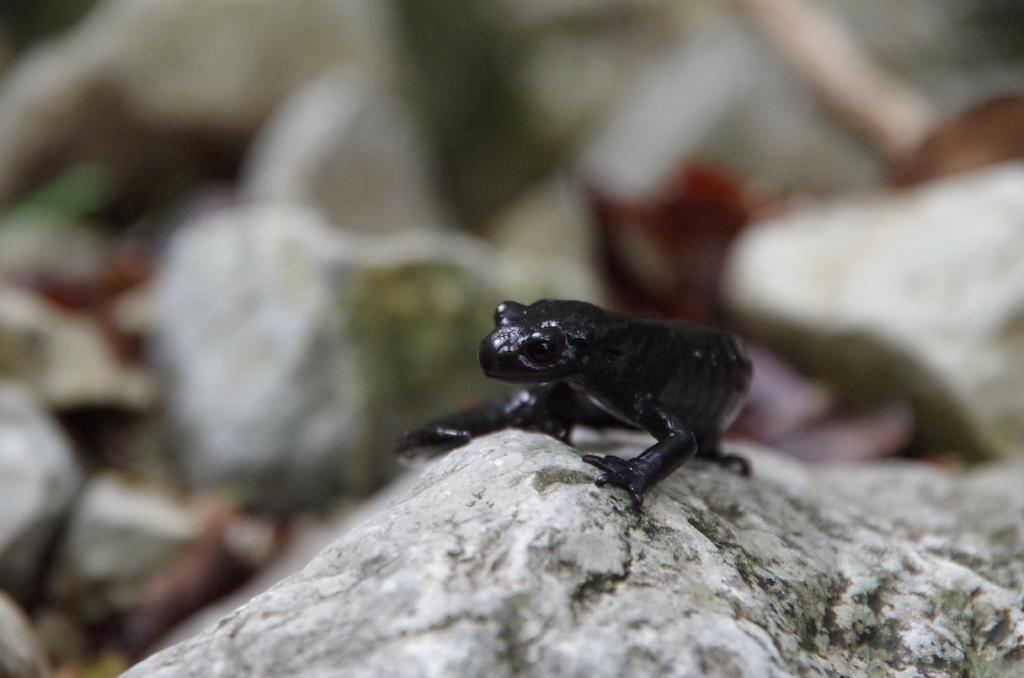Could you give a brief overview of what you see in this image? At the bottom of the image there are some stones, on the stone there is a frog. Background of the image is blur. 